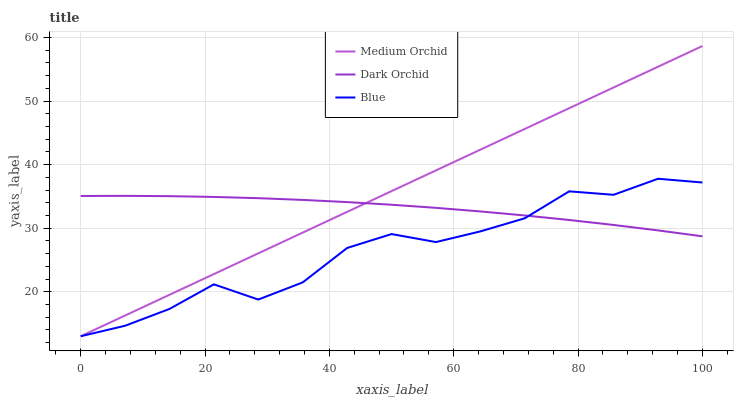Does Dark Orchid have the minimum area under the curve?
Answer yes or no. No. Does Dark Orchid have the maximum area under the curve?
Answer yes or no. No. Is Dark Orchid the smoothest?
Answer yes or no. No. Is Dark Orchid the roughest?
Answer yes or no. No. Does Dark Orchid have the lowest value?
Answer yes or no. No. Does Dark Orchid have the highest value?
Answer yes or no. No. 